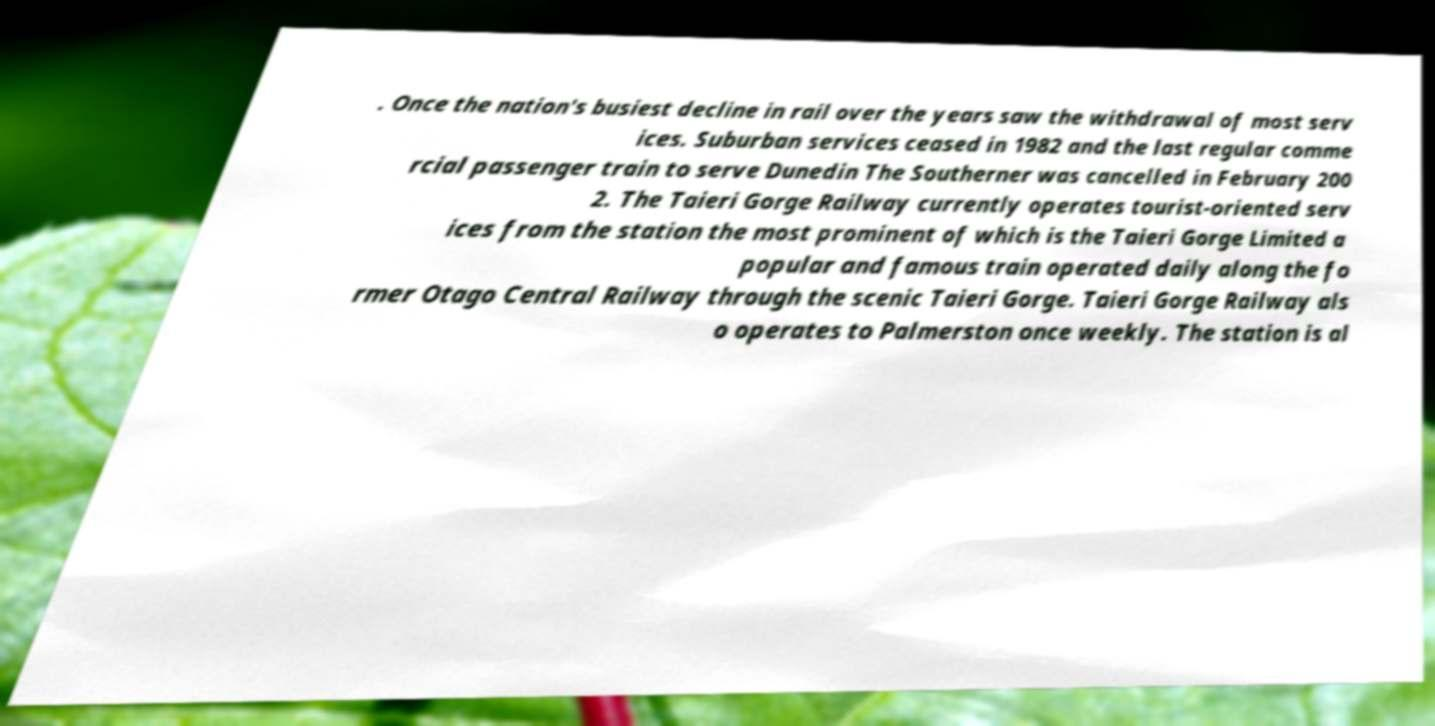Could you extract and type out the text from this image? . Once the nation's busiest decline in rail over the years saw the withdrawal of most serv ices. Suburban services ceased in 1982 and the last regular comme rcial passenger train to serve Dunedin The Southerner was cancelled in February 200 2. The Taieri Gorge Railway currently operates tourist-oriented serv ices from the station the most prominent of which is the Taieri Gorge Limited a popular and famous train operated daily along the fo rmer Otago Central Railway through the scenic Taieri Gorge. Taieri Gorge Railway als o operates to Palmerston once weekly. The station is al 